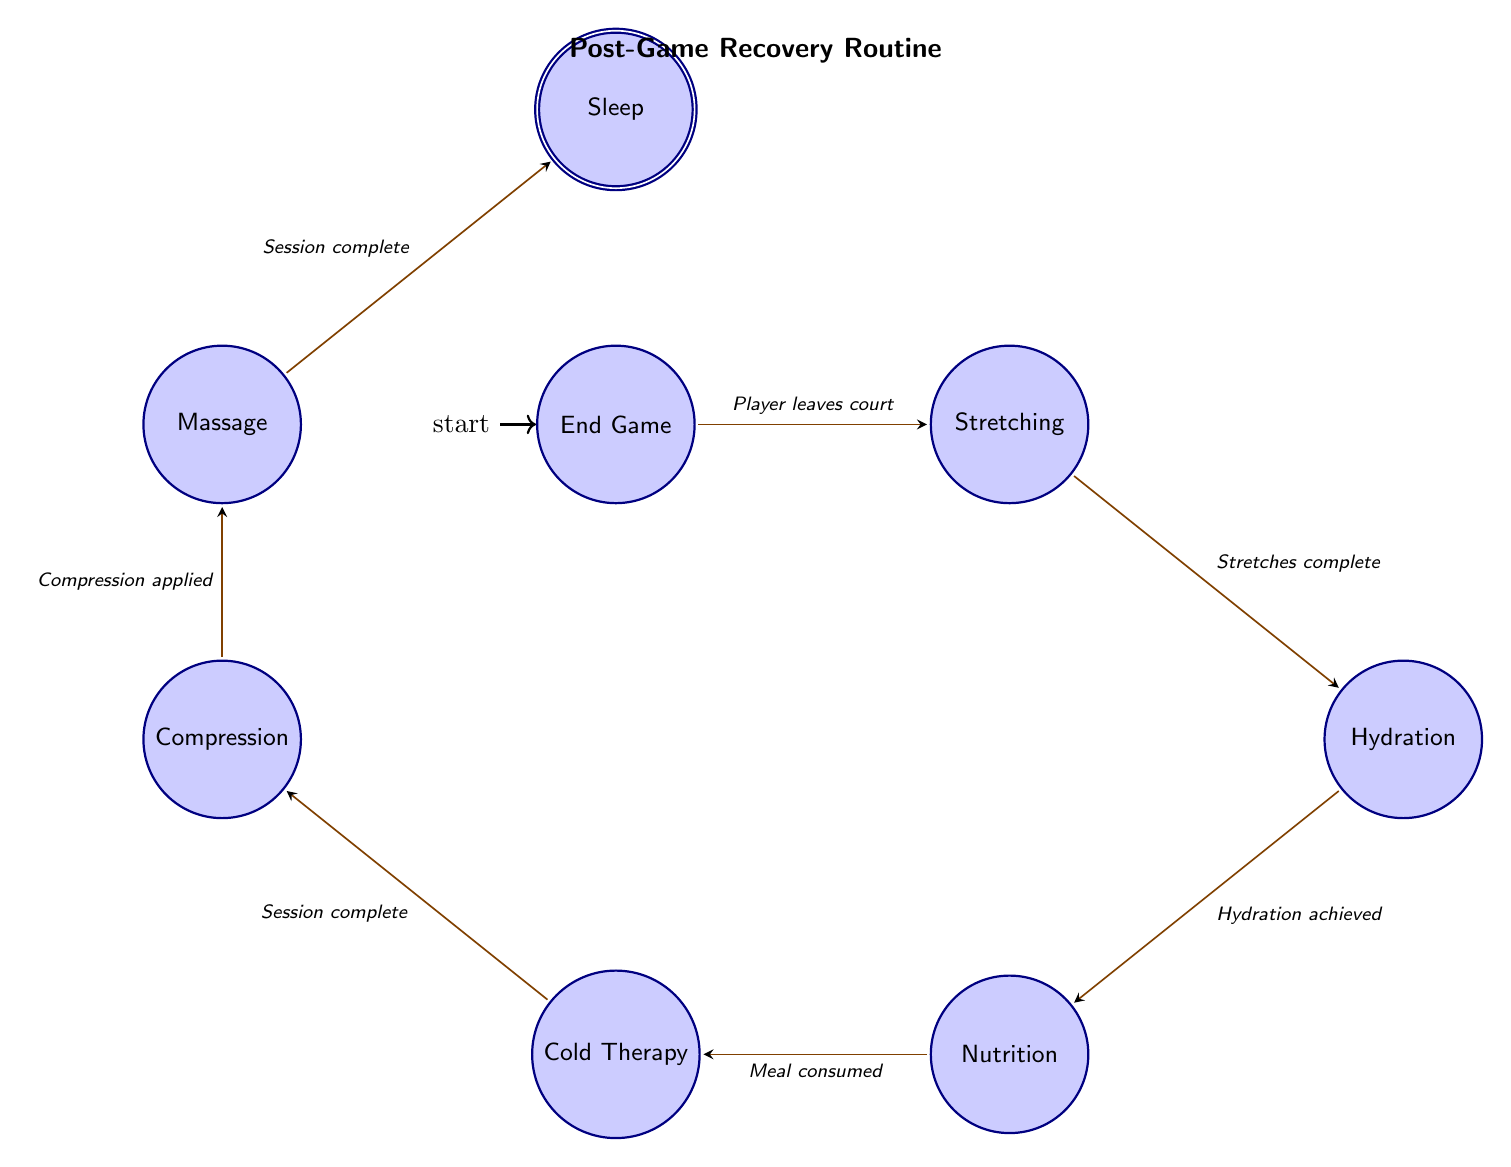What is the first state in the recovery routine? The diagram begins at the "EndGame" state, which is indicated as the initial state.
Answer: EndGame How many nodes are in the finite state machine? The diagram includes a total of 8 states: EndGame, Stretching, Hydration, Nutrition, ColdTherapy, Compression, Massage, and Sleep, which can be counted directly from the diagram.
Answer: 8 What action follows the "Stretching" state? The transition arrow from "Stretching" goes to "Hydration," indicating that hydration is the next action after stretching.
Answer: Hydration What is the condition to transition from "Nutrition" to "ColdTherapy"? The diagram states that the transition occurs when the "Meal consumed" condition is met after completing nutrition.
Answer: Meal consumed Which state comes after "Compression"? Following the "Compression" state, the next state is "Massage," as indicated by the direction of the transition arrow.
Answer: Massage How many transitions are there in total? By examining the transitions listed between the states, there are 7 transitions connecting the various states in the recovery routine.
Answer: 7 What is required to transition from "Massage" to "Sleep"? The necessary condition to move from "Massage" to "Sleep" is that the "Session complete" condition must be achieved, as noted in the transition description.
Answer: Session complete What is the final state of the recovery routine? The "Sleep" state is marked as the final or accepting state in the diagram, indicating it is the last step in the routine.
Answer: Sleep 